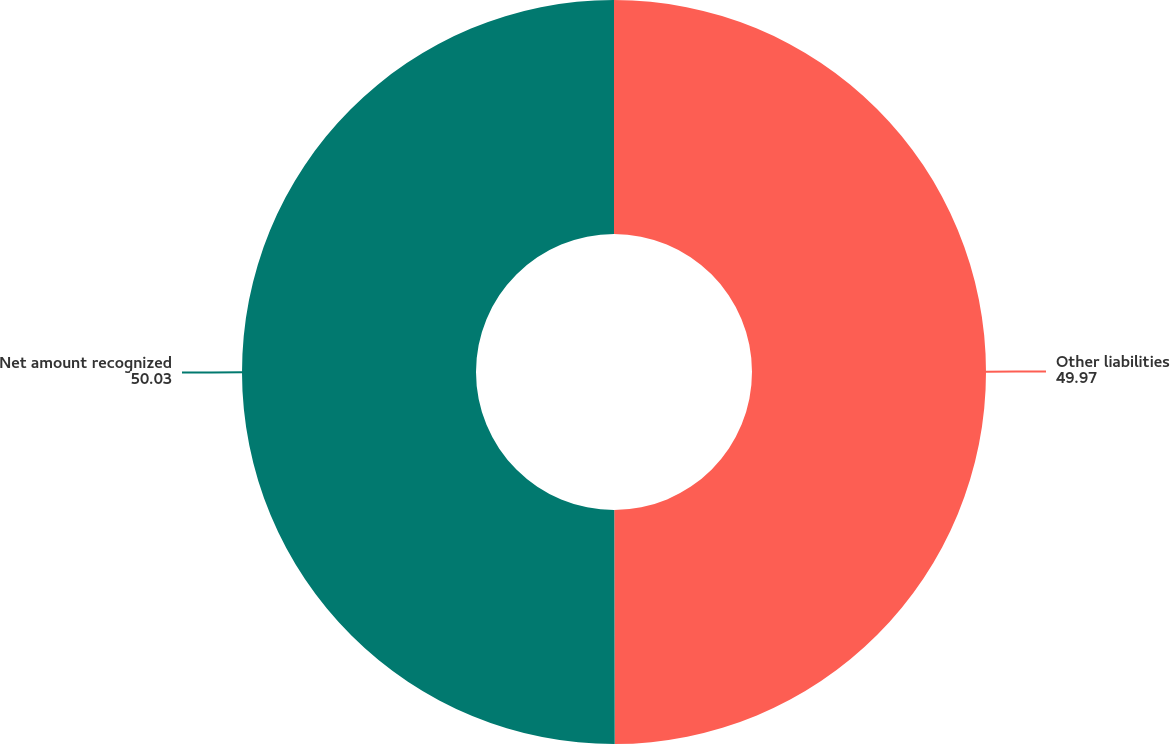Convert chart to OTSL. <chart><loc_0><loc_0><loc_500><loc_500><pie_chart><fcel>Other liabilities<fcel>Net amount recognized<nl><fcel>49.97%<fcel>50.03%<nl></chart> 